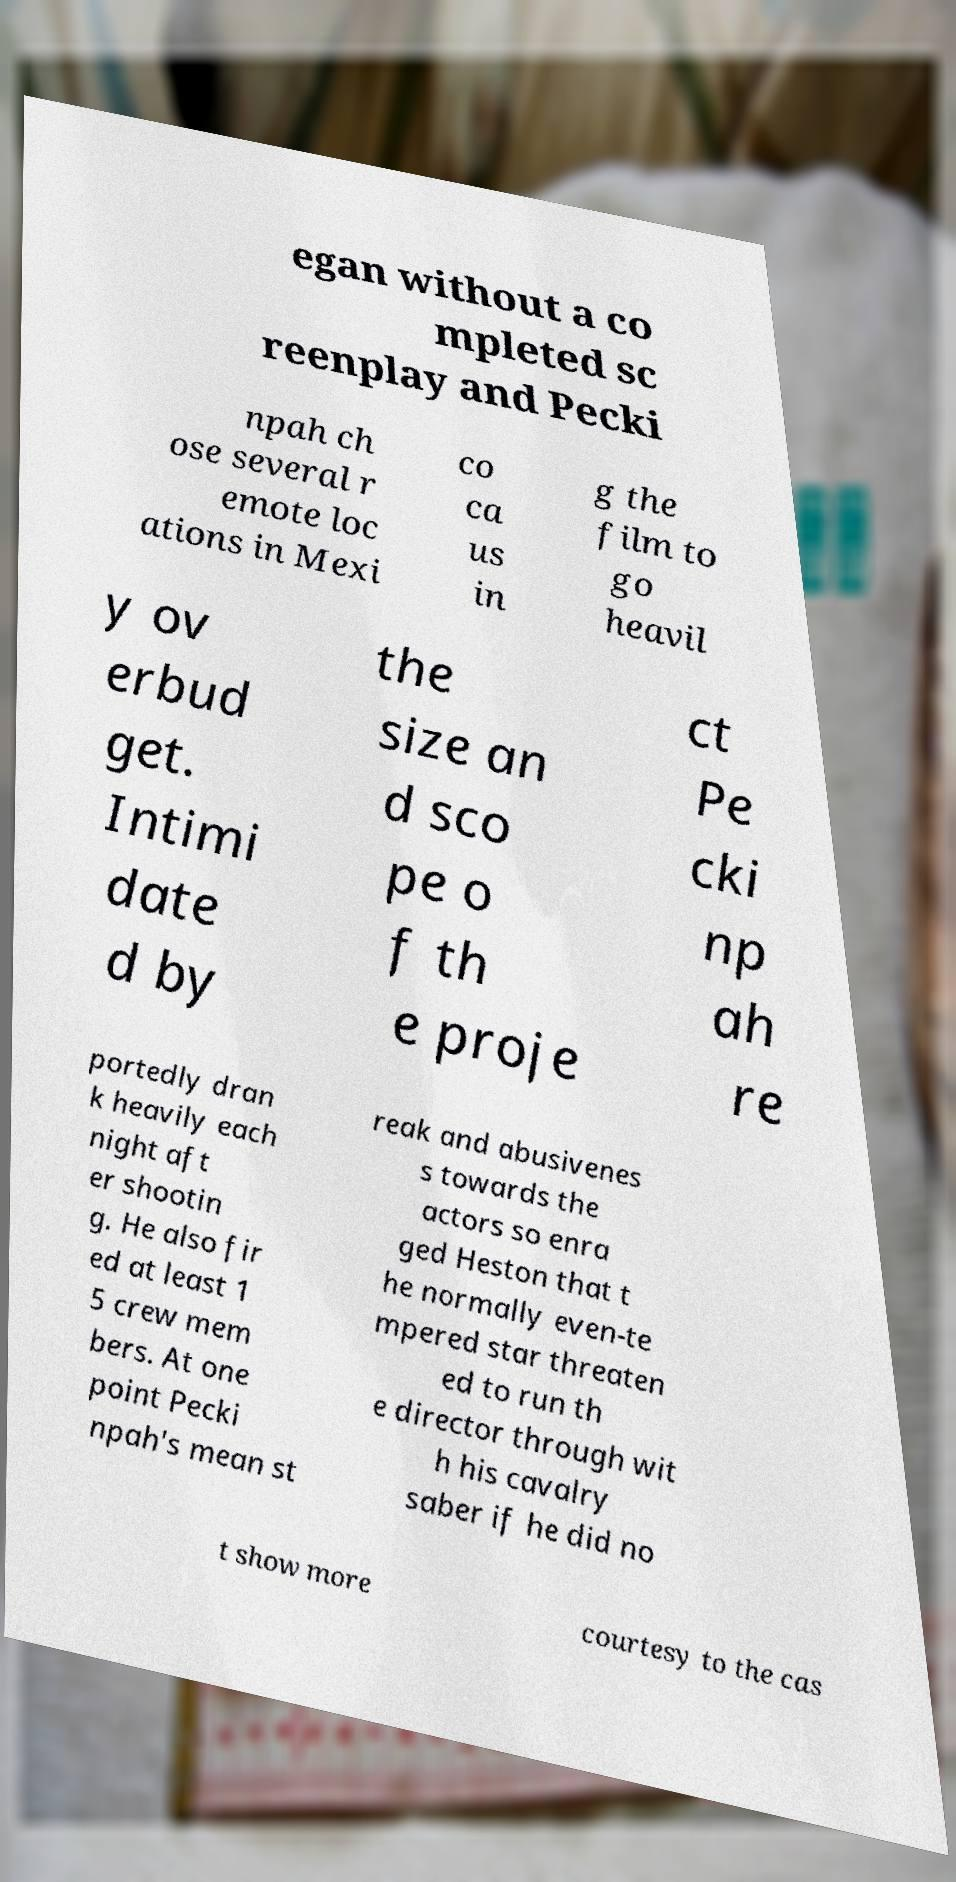Could you assist in decoding the text presented in this image and type it out clearly? egan without a co mpleted sc reenplay and Pecki npah ch ose several r emote loc ations in Mexi co ca us in g the film to go heavil y ov erbud get. Intimi date d by the size an d sco pe o f th e proje ct Pe cki np ah re portedly dran k heavily each night aft er shootin g. He also fir ed at least 1 5 crew mem bers. At one point Pecki npah's mean st reak and abusivenes s towards the actors so enra ged Heston that t he normally even-te mpered star threaten ed to run th e director through wit h his cavalry saber if he did no t show more courtesy to the cas 